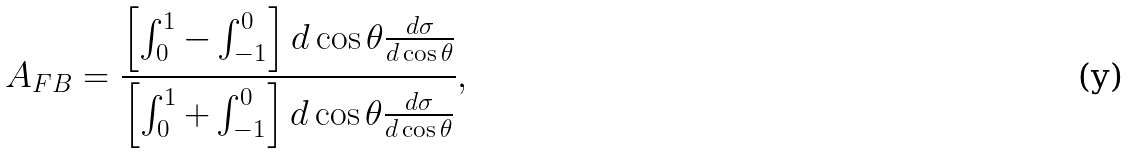Convert formula to latex. <formula><loc_0><loc_0><loc_500><loc_500>A _ { F B } = \frac { \left [ \int _ { 0 } ^ { 1 } - \int _ { - 1 } ^ { 0 } \right ] d \cos \theta \frac { d \sigma } { d \cos \theta } } { \left [ \int _ { 0 } ^ { 1 } + \int _ { - 1 } ^ { 0 } \right ] d \cos \theta \frac { d \sigma } { d \cos \theta } } ,</formula> 